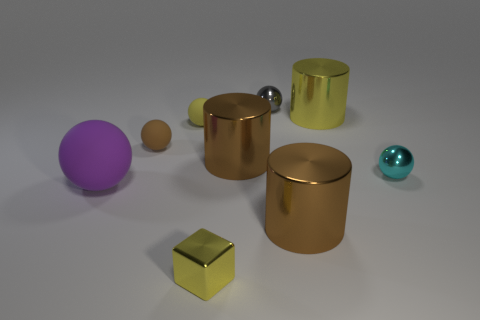Subtract 3 balls. How many balls are left? 2 Subtract all tiny yellow balls. How many balls are left? 4 Subtract 1 cyan balls. How many objects are left? 8 Subtract all blocks. How many objects are left? 8 Subtract all brown balls. Subtract all blue blocks. How many balls are left? 4 Subtract all cyan spheres. How many yellow cylinders are left? 1 Subtract all small cyan metallic spheres. Subtract all rubber spheres. How many objects are left? 5 Add 1 yellow matte spheres. How many yellow matte spheres are left? 2 Add 2 big brown things. How many big brown things exist? 4 Add 1 brown shiny objects. How many objects exist? 10 